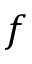Convert formula to latex. <formula><loc_0><loc_0><loc_500><loc_500>f</formula> 